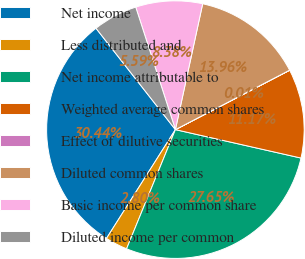Convert chart to OTSL. <chart><loc_0><loc_0><loc_500><loc_500><pie_chart><fcel>Net income<fcel>Less distributed and<fcel>Net income attributable to<fcel>Weighted average common shares<fcel>Effect of dilutive securities<fcel>Diluted common shares<fcel>Basic income per common share<fcel>Diluted income per common<nl><fcel>30.43%<fcel>2.8%<fcel>27.64%<fcel>11.17%<fcel>0.01%<fcel>13.96%<fcel>8.38%<fcel>5.59%<nl></chart> 